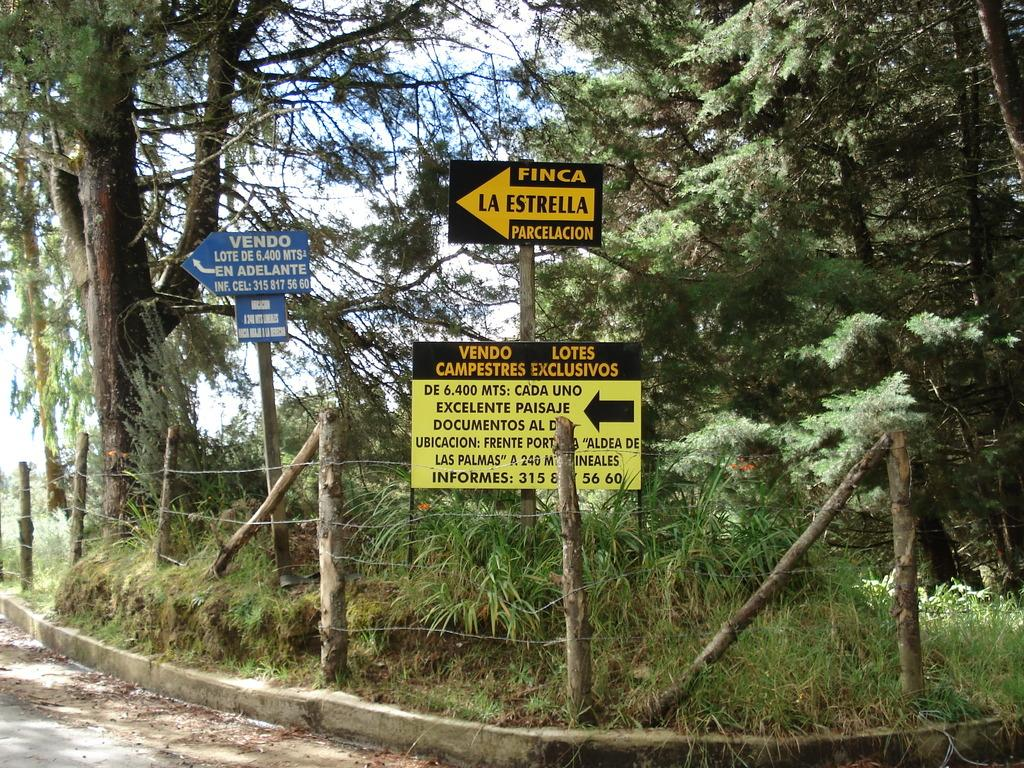What type of vegetation can be seen in the image? There are trees in the image. Where are the trees located? The trees are located on a road. What else can be seen in the image besides the trees? There is fencing and sign boards in the image. What discovery was made by the society in the image? There is no indication of a discovery or society in the image; it simply shows trees, a road, fencing, and sign boards. 